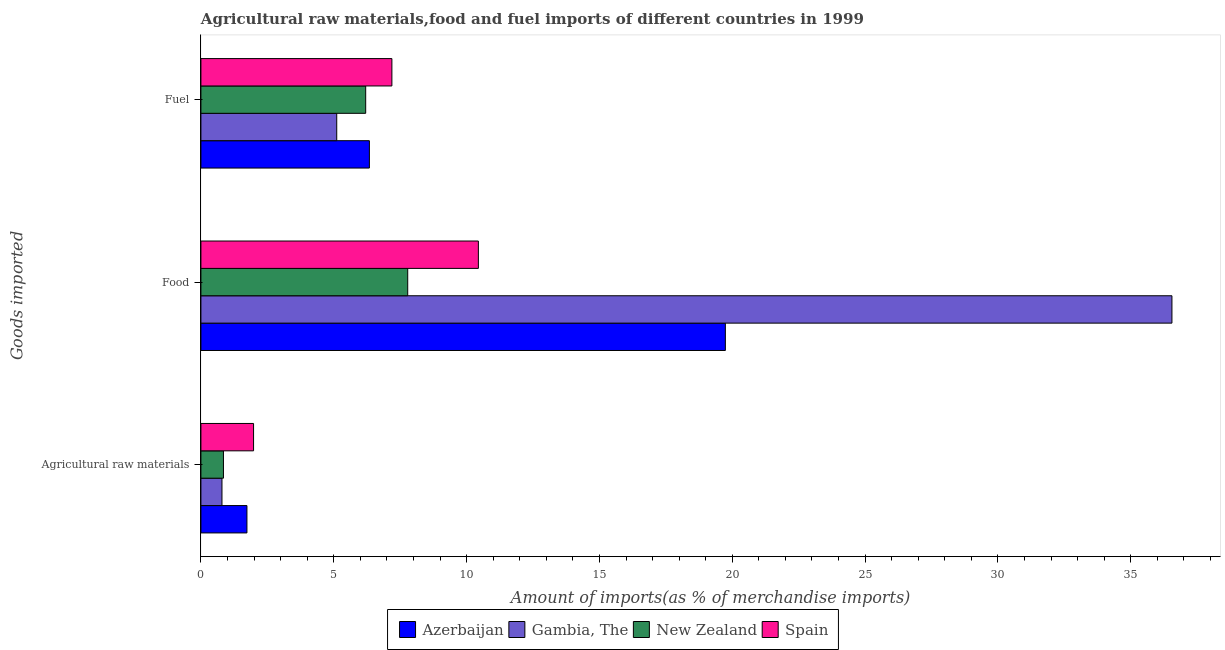How many different coloured bars are there?
Provide a succinct answer. 4. How many groups of bars are there?
Your response must be concise. 3. What is the label of the 2nd group of bars from the top?
Provide a succinct answer. Food. What is the percentage of food imports in Gambia, The?
Your response must be concise. 36.55. Across all countries, what is the maximum percentage of fuel imports?
Ensure brevity in your answer.  7.19. Across all countries, what is the minimum percentage of fuel imports?
Provide a succinct answer. 5.11. In which country was the percentage of raw materials imports maximum?
Keep it short and to the point. Spain. In which country was the percentage of food imports minimum?
Your response must be concise. New Zealand. What is the total percentage of food imports in the graph?
Your answer should be compact. 74.52. What is the difference between the percentage of fuel imports in Gambia, The and that in Spain?
Ensure brevity in your answer.  -2.08. What is the difference between the percentage of food imports in Spain and the percentage of fuel imports in Gambia, The?
Offer a very short reply. 5.33. What is the average percentage of fuel imports per country?
Offer a very short reply. 6.21. What is the difference between the percentage of food imports and percentage of raw materials imports in Azerbaijan?
Your answer should be compact. 18.01. What is the ratio of the percentage of raw materials imports in Spain to that in New Zealand?
Keep it short and to the point. 2.34. Is the percentage of raw materials imports in New Zealand less than that in Azerbaijan?
Offer a terse response. Yes. Is the difference between the percentage of food imports in New Zealand and Spain greater than the difference between the percentage of fuel imports in New Zealand and Spain?
Offer a very short reply. No. What is the difference between the highest and the second highest percentage of fuel imports?
Ensure brevity in your answer.  0.85. What is the difference between the highest and the lowest percentage of fuel imports?
Give a very brief answer. 2.08. Is the sum of the percentage of raw materials imports in Gambia, The and New Zealand greater than the maximum percentage of food imports across all countries?
Ensure brevity in your answer.  No. What does the 3rd bar from the top in Agricultural raw materials represents?
Give a very brief answer. Gambia, The. What does the 1st bar from the bottom in Fuel represents?
Provide a succinct answer. Azerbaijan. How many bars are there?
Make the answer very short. 12. Where does the legend appear in the graph?
Keep it short and to the point. Bottom center. How are the legend labels stacked?
Keep it short and to the point. Horizontal. What is the title of the graph?
Make the answer very short. Agricultural raw materials,food and fuel imports of different countries in 1999. What is the label or title of the X-axis?
Provide a succinct answer. Amount of imports(as % of merchandise imports). What is the label or title of the Y-axis?
Offer a terse response. Goods imported. What is the Amount of imports(as % of merchandise imports) of Azerbaijan in Agricultural raw materials?
Offer a very short reply. 1.73. What is the Amount of imports(as % of merchandise imports) in Gambia, The in Agricultural raw materials?
Keep it short and to the point. 0.79. What is the Amount of imports(as % of merchandise imports) of New Zealand in Agricultural raw materials?
Offer a very short reply. 0.85. What is the Amount of imports(as % of merchandise imports) of Spain in Agricultural raw materials?
Offer a very short reply. 1.98. What is the Amount of imports(as % of merchandise imports) of Azerbaijan in Food?
Make the answer very short. 19.74. What is the Amount of imports(as % of merchandise imports) of Gambia, The in Food?
Your response must be concise. 36.55. What is the Amount of imports(as % of merchandise imports) in New Zealand in Food?
Offer a very short reply. 7.78. What is the Amount of imports(as % of merchandise imports) in Spain in Food?
Make the answer very short. 10.44. What is the Amount of imports(as % of merchandise imports) of Azerbaijan in Fuel?
Give a very brief answer. 6.34. What is the Amount of imports(as % of merchandise imports) of Gambia, The in Fuel?
Offer a terse response. 5.11. What is the Amount of imports(as % of merchandise imports) of New Zealand in Fuel?
Provide a succinct answer. 6.2. What is the Amount of imports(as % of merchandise imports) in Spain in Fuel?
Ensure brevity in your answer.  7.19. Across all Goods imported, what is the maximum Amount of imports(as % of merchandise imports) of Azerbaijan?
Offer a very short reply. 19.74. Across all Goods imported, what is the maximum Amount of imports(as % of merchandise imports) in Gambia, The?
Offer a very short reply. 36.55. Across all Goods imported, what is the maximum Amount of imports(as % of merchandise imports) of New Zealand?
Provide a short and direct response. 7.78. Across all Goods imported, what is the maximum Amount of imports(as % of merchandise imports) in Spain?
Your response must be concise. 10.44. Across all Goods imported, what is the minimum Amount of imports(as % of merchandise imports) in Azerbaijan?
Make the answer very short. 1.73. Across all Goods imported, what is the minimum Amount of imports(as % of merchandise imports) of Gambia, The?
Offer a very short reply. 0.79. Across all Goods imported, what is the minimum Amount of imports(as % of merchandise imports) in New Zealand?
Provide a succinct answer. 0.85. Across all Goods imported, what is the minimum Amount of imports(as % of merchandise imports) of Spain?
Provide a short and direct response. 1.98. What is the total Amount of imports(as % of merchandise imports) of Azerbaijan in the graph?
Provide a succinct answer. 27.81. What is the total Amount of imports(as % of merchandise imports) in Gambia, The in the graph?
Keep it short and to the point. 42.45. What is the total Amount of imports(as % of merchandise imports) of New Zealand in the graph?
Offer a very short reply. 14.83. What is the total Amount of imports(as % of merchandise imports) of Spain in the graph?
Keep it short and to the point. 19.61. What is the difference between the Amount of imports(as % of merchandise imports) of Azerbaijan in Agricultural raw materials and that in Food?
Keep it short and to the point. -18.01. What is the difference between the Amount of imports(as % of merchandise imports) of Gambia, The in Agricultural raw materials and that in Food?
Provide a short and direct response. -35.76. What is the difference between the Amount of imports(as % of merchandise imports) in New Zealand in Agricultural raw materials and that in Food?
Ensure brevity in your answer.  -6.94. What is the difference between the Amount of imports(as % of merchandise imports) in Spain in Agricultural raw materials and that in Food?
Provide a succinct answer. -8.46. What is the difference between the Amount of imports(as % of merchandise imports) of Azerbaijan in Agricultural raw materials and that in Fuel?
Your answer should be very brief. -4.61. What is the difference between the Amount of imports(as % of merchandise imports) in Gambia, The in Agricultural raw materials and that in Fuel?
Your answer should be very brief. -4.32. What is the difference between the Amount of imports(as % of merchandise imports) in New Zealand in Agricultural raw materials and that in Fuel?
Give a very brief answer. -5.35. What is the difference between the Amount of imports(as % of merchandise imports) of Spain in Agricultural raw materials and that in Fuel?
Your response must be concise. -5.21. What is the difference between the Amount of imports(as % of merchandise imports) in Azerbaijan in Food and that in Fuel?
Give a very brief answer. 13.4. What is the difference between the Amount of imports(as % of merchandise imports) in Gambia, The in Food and that in Fuel?
Provide a succinct answer. 31.44. What is the difference between the Amount of imports(as % of merchandise imports) in New Zealand in Food and that in Fuel?
Offer a very short reply. 1.58. What is the difference between the Amount of imports(as % of merchandise imports) in Spain in Food and that in Fuel?
Your answer should be very brief. 3.26. What is the difference between the Amount of imports(as % of merchandise imports) in Azerbaijan in Agricultural raw materials and the Amount of imports(as % of merchandise imports) in Gambia, The in Food?
Offer a very short reply. -34.82. What is the difference between the Amount of imports(as % of merchandise imports) of Azerbaijan in Agricultural raw materials and the Amount of imports(as % of merchandise imports) of New Zealand in Food?
Provide a succinct answer. -6.05. What is the difference between the Amount of imports(as % of merchandise imports) in Azerbaijan in Agricultural raw materials and the Amount of imports(as % of merchandise imports) in Spain in Food?
Make the answer very short. -8.71. What is the difference between the Amount of imports(as % of merchandise imports) of Gambia, The in Agricultural raw materials and the Amount of imports(as % of merchandise imports) of New Zealand in Food?
Give a very brief answer. -6.99. What is the difference between the Amount of imports(as % of merchandise imports) in Gambia, The in Agricultural raw materials and the Amount of imports(as % of merchandise imports) in Spain in Food?
Keep it short and to the point. -9.65. What is the difference between the Amount of imports(as % of merchandise imports) in New Zealand in Agricultural raw materials and the Amount of imports(as % of merchandise imports) in Spain in Food?
Keep it short and to the point. -9.6. What is the difference between the Amount of imports(as % of merchandise imports) in Azerbaijan in Agricultural raw materials and the Amount of imports(as % of merchandise imports) in Gambia, The in Fuel?
Provide a succinct answer. -3.38. What is the difference between the Amount of imports(as % of merchandise imports) in Azerbaijan in Agricultural raw materials and the Amount of imports(as % of merchandise imports) in New Zealand in Fuel?
Your answer should be compact. -4.47. What is the difference between the Amount of imports(as % of merchandise imports) of Azerbaijan in Agricultural raw materials and the Amount of imports(as % of merchandise imports) of Spain in Fuel?
Offer a terse response. -5.46. What is the difference between the Amount of imports(as % of merchandise imports) of Gambia, The in Agricultural raw materials and the Amount of imports(as % of merchandise imports) of New Zealand in Fuel?
Your answer should be compact. -5.41. What is the difference between the Amount of imports(as % of merchandise imports) of Gambia, The in Agricultural raw materials and the Amount of imports(as % of merchandise imports) of Spain in Fuel?
Provide a short and direct response. -6.4. What is the difference between the Amount of imports(as % of merchandise imports) in New Zealand in Agricultural raw materials and the Amount of imports(as % of merchandise imports) in Spain in Fuel?
Offer a terse response. -6.34. What is the difference between the Amount of imports(as % of merchandise imports) in Azerbaijan in Food and the Amount of imports(as % of merchandise imports) in Gambia, The in Fuel?
Offer a terse response. 14.63. What is the difference between the Amount of imports(as % of merchandise imports) of Azerbaijan in Food and the Amount of imports(as % of merchandise imports) of New Zealand in Fuel?
Keep it short and to the point. 13.54. What is the difference between the Amount of imports(as % of merchandise imports) in Azerbaijan in Food and the Amount of imports(as % of merchandise imports) in Spain in Fuel?
Keep it short and to the point. 12.55. What is the difference between the Amount of imports(as % of merchandise imports) in Gambia, The in Food and the Amount of imports(as % of merchandise imports) in New Zealand in Fuel?
Give a very brief answer. 30.35. What is the difference between the Amount of imports(as % of merchandise imports) in Gambia, The in Food and the Amount of imports(as % of merchandise imports) in Spain in Fuel?
Your response must be concise. 29.36. What is the difference between the Amount of imports(as % of merchandise imports) in New Zealand in Food and the Amount of imports(as % of merchandise imports) in Spain in Fuel?
Your answer should be very brief. 0.6. What is the average Amount of imports(as % of merchandise imports) of Azerbaijan per Goods imported?
Your response must be concise. 9.27. What is the average Amount of imports(as % of merchandise imports) of Gambia, The per Goods imported?
Your answer should be very brief. 14.15. What is the average Amount of imports(as % of merchandise imports) of New Zealand per Goods imported?
Your answer should be very brief. 4.94. What is the average Amount of imports(as % of merchandise imports) of Spain per Goods imported?
Ensure brevity in your answer.  6.54. What is the difference between the Amount of imports(as % of merchandise imports) of Azerbaijan and Amount of imports(as % of merchandise imports) of New Zealand in Agricultural raw materials?
Your response must be concise. 0.88. What is the difference between the Amount of imports(as % of merchandise imports) of Azerbaijan and Amount of imports(as % of merchandise imports) of Spain in Agricultural raw materials?
Offer a terse response. -0.25. What is the difference between the Amount of imports(as % of merchandise imports) in Gambia, The and Amount of imports(as % of merchandise imports) in New Zealand in Agricultural raw materials?
Give a very brief answer. -0.06. What is the difference between the Amount of imports(as % of merchandise imports) in Gambia, The and Amount of imports(as % of merchandise imports) in Spain in Agricultural raw materials?
Give a very brief answer. -1.19. What is the difference between the Amount of imports(as % of merchandise imports) in New Zealand and Amount of imports(as % of merchandise imports) in Spain in Agricultural raw materials?
Offer a very short reply. -1.13. What is the difference between the Amount of imports(as % of merchandise imports) in Azerbaijan and Amount of imports(as % of merchandise imports) in Gambia, The in Food?
Make the answer very short. -16.81. What is the difference between the Amount of imports(as % of merchandise imports) of Azerbaijan and Amount of imports(as % of merchandise imports) of New Zealand in Food?
Your answer should be compact. 11.96. What is the difference between the Amount of imports(as % of merchandise imports) in Azerbaijan and Amount of imports(as % of merchandise imports) in Spain in Food?
Offer a terse response. 9.3. What is the difference between the Amount of imports(as % of merchandise imports) in Gambia, The and Amount of imports(as % of merchandise imports) in New Zealand in Food?
Offer a very short reply. 28.77. What is the difference between the Amount of imports(as % of merchandise imports) in Gambia, The and Amount of imports(as % of merchandise imports) in Spain in Food?
Offer a terse response. 26.11. What is the difference between the Amount of imports(as % of merchandise imports) of New Zealand and Amount of imports(as % of merchandise imports) of Spain in Food?
Give a very brief answer. -2.66. What is the difference between the Amount of imports(as % of merchandise imports) of Azerbaijan and Amount of imports(as % of merchandise imports) of Gambia, The in Fuel?
Keep it short and to the point. 1.23. What is the difference between the Amount of imports(as % of merchandise imports) in Azerbaijan and Amount of imports(as % of merchandise imports) in New Zealand in Fuel?
Keep it short and to the point. 0.14. What is the difference between the Amount of imports(as % of merchandise imports) in Azerbaijan and Amount of imports(as % of merchandise imports) in Spain in Fuel?
Keep it short and to the point. -0.85. What is the difference between the Amount of imports(as % of merchandise imports) of Gambia, The and Amount of imports(as % of merchandise imports) of New Zealand in Fuel?
Your answer should be very brief. -1.09. What is the difference between the Amount of imports(as % of merchandise imports) of Gambia, The and Amount of imports(as % of merchandise imports) of Spain in Fuel?
Offer a very short reply. -2.08. What is the difference between the Amount of imports(as % of merchandise imports) of New Zealand and Amount of imports(as % of merchandise imports) of Spain in Fuel?
Your answer should be compact. -0.99. What is the ratio of the Amount of imports(as % of merchandise imports) of Azerbaijan in Agricultural raw materials to that in Food?
Keep it short and to the point. 0.09. What is the ratio of the Amount of imports(as % of merchandise imports) of Gambia, The in Agricultural raw materials to that in Food?
Keep it short and to the point. 0.02. What is the ratio of the Amount of imports(as % of merchandise imports) in New Zealand in Agricultural raw materials to that in Food?
Offer a terse response. 0.11. What is the ratio of the Amount of imports(as % of merchandise imports) in Spain in Agricultural raw materials to that in Food?
Make the answer very short. 0.19. What is the ratio of the Amount of imports(as % of merchandise imports) of Azerbaijan in Agricultural raw materials to that in Fuel?
Your response must be concise. 0.27. What is the ratio of the Amount of imports(as % of merchandise imports) of Gambia, The in Agricultural raw materials to that in Fuel?
Offer a very short reply. 0.15. What is the ratio of the Amount of imports(as % of merchandise imports) of New Zealand in Agricultural raw materials to that in Fuel?
Offer a very short reply. 0.14. What is the ratio of the Amount of imports(as % of merchandise imports) of Spain in Agricultural raw materials to that in Fuel?
Your response must be concise. 0.28. What is the ratio of the Amount of imports(as % of merchandise imports) of Azerbaijan in Food to that in Fuel?
Your answer should be very brief. 3.11. What is the ratio of the Amount of imports(as % of merchandise imports) of Gambia, The in Food to that in Fuel?
Offer a very short reply. 7.15. What is the ratio of the Amount of imports(as % of merchandise imports) of New Zealand in Food to that in Fuel?
Your response must be concise. 1.25. What is the ratio of the Amount of imports(as % of merchandise imports) in Spain in Food to that in Fuel?
Offer a very short reply. 1.45. What is the difference between the highest and the second highest Amount of imports(as % of merchandise imports) of Azerbaijan?
Offer a very short reply. 13.4. What is the difference between the highest and the second highest Amount of imports(as % of merchandise imports) in Gambia, The?
Keep it short and to the point. 31.44. What is the difference between the highest and the second highest Amount of imports(as % of merchandise imports) in New Zealand?
Your answer should be compact. 1.58. What is the difference between the highest and the second highest Amount of imports(as % of merchandise imports) of Spain?
Provide a short and direct response. 3.26. What is the difference between the highest and the lowest Amount of imports(as % of merchandise imports) in Azerbaijan?
Offer a terse response. 18.01. What is the difference between the highest and the lowest Amount of imports(as % of merchandise imports) in Gambia, The?
Provide a short and direct response. 35.76. What is the difference between the highest and the lowest Amount of imports(as % of merchandise imports) in New Zealand?
Give a very brief answer. 6.94. What is the difference between the highest and the lowest Amount of imports(as % of merchandise imports) in Spain?
Give a very brief answer. 8.46. 